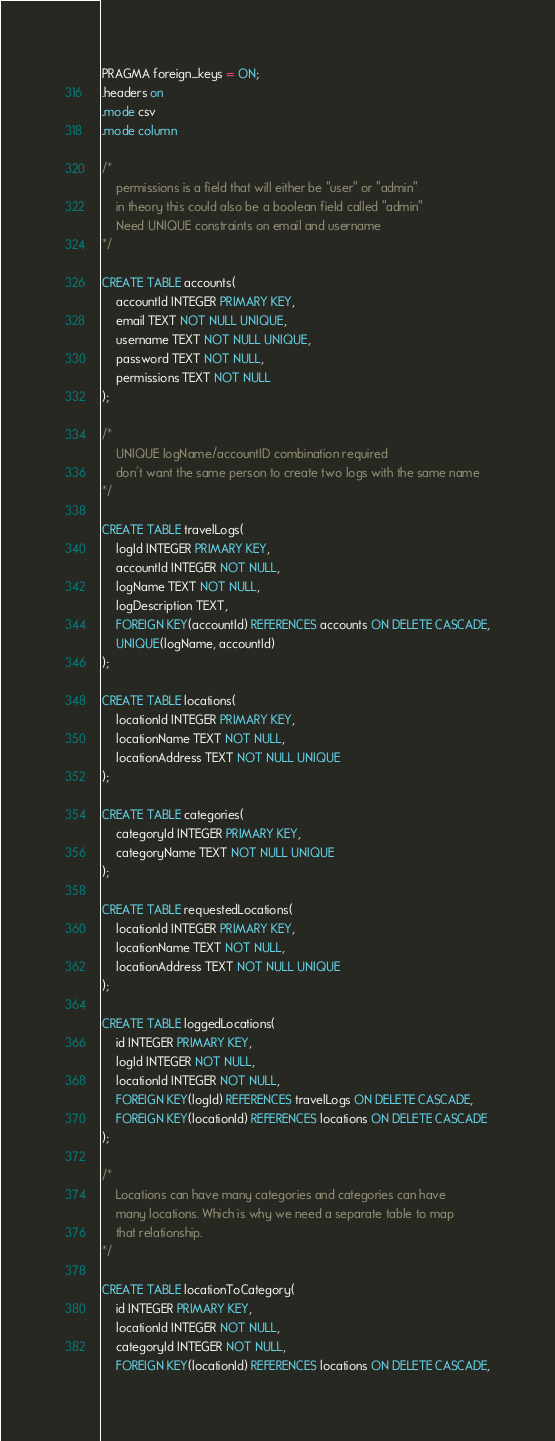<code> <loc_0><loc_0><loc_500><loc_500><_SQL_>PRAGMA foreign_keys = ON;
.headers on
.mode csv
.mode column

/*
	permissions is a field that will either be "user" or "admin"
	in theory this could also be a boolean field called "admin"
	Need UNIQUE constraints on email and username
*/

CREATE TABLE accounts(
	accountId INTEGER PRIMARY KEY,
	email TEXT NOT NULL UNIQUE,
	username TEXT NOT NULL UNIQUE,
	password TEXT NOT NULL,
	permissions TEXT NOT NULL
);

/*
	UNIQUE logName/accountID combination required
	don't want the same person to create two logs with the same name
*/

CREATE TABLE travelLogs(
	logId INTEGER PRIMARY KEY,
	accountId INTEGER NOT NULL,
	logName TEXT NOT NULL,
	logDescription TEXT,
	FOREIGN KEY(accountId) REFERENCES accounts ON DELETE CASCADE,
	UNIQUE(logName, accountId)
);

CREATE TABLE locations(
	locationId INTEGER PRIMARY KEY,
	locationName TEXT NOT NULL,
	locationAddress TEXT NOT NULL UNIQUE
);

CREATE TABLE categories(
	categoryId INTEGER PRIMARY KEY,
	categoryName TEXT NOT NULL UNIQUE
);

CREATE TABLE requestedLocations(
	locationId INTEGER PRIMARY KEY,
	locationName TEXT NOT NULL,
	locationAddress TEXT NOT NULL UNIQUE
);

CREATE TABLE loggedLocations(
	id INTEGER PRIMARY KEY,
	logId INTEGER NOT NULL,
	locationId INTEGER NOT NULL,
	FOREIGN KEY(logId) REFERENCES travelLogs ON DELETE CASCADE,
	FOREIGN KEY(locationId) REFERENCES locations ON DELETE CASCADE
);

/*
	Locations can have many categories and categories can have
	many locations. Which is why we need a separate table to map
	that relationship.
*/

CREATE TABLE locationToCategory(
	id INTEGER PRIMARY KEY,
	locationId INTEGER NOT NULL,
	categoryId INTEGER NOT NULL,
	FOREIGN KEY(locationId) REFERENCES locations ON DELETE CASCADE,</code> 